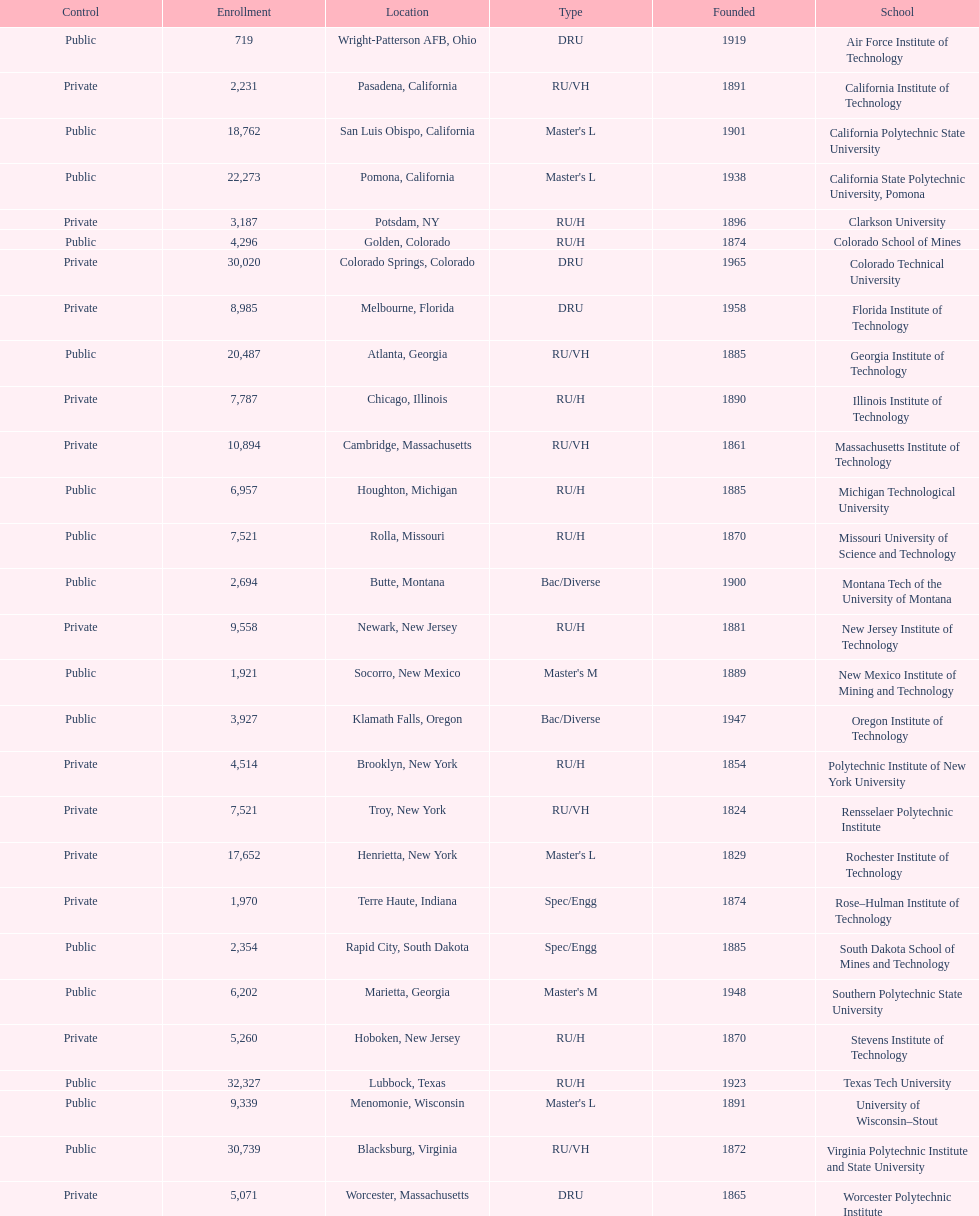Which school had the largest enrollment? Texas Tech University. 